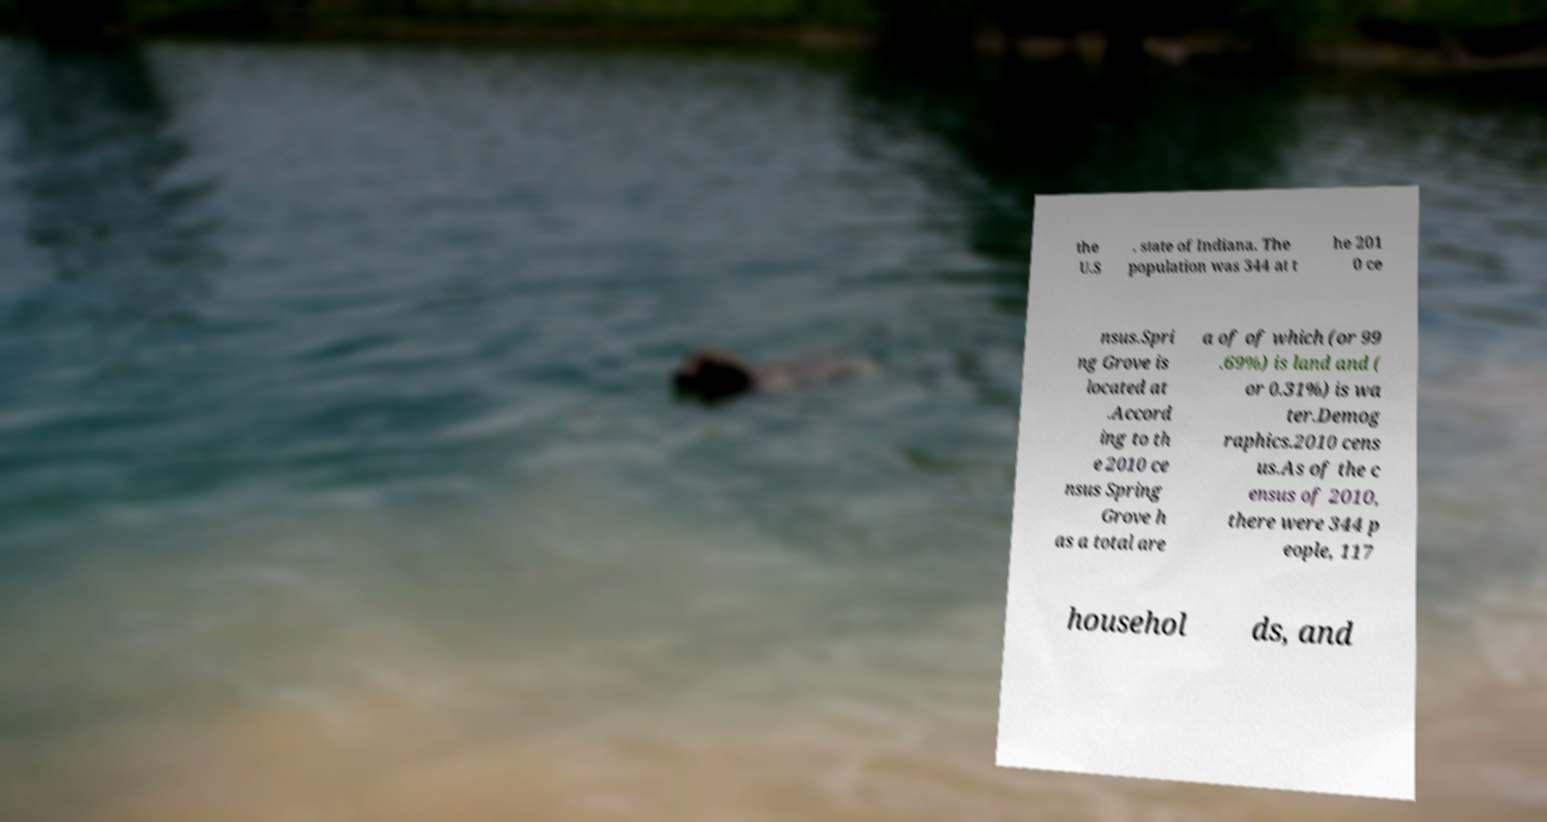Can you accurately transcribe the text from the provided image for me? the U.S . state of Indiana. The population was 344 at t he 201 0 ce nsus.Spri ng Grove is located at .Accord ing to th e 2010 ce nsus Spring Grove h as a total are a of of which (or 99 .69%) is land and ( or 0.31%) is wa ter.Demog raphics.2010 cens us.As of the c ensus of 2010, there were 344 p eople, 117 househol ds, and 